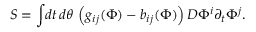<formula> <loc_0><loc_0><loc_500><loc_500>S = \int \, d t \, d \theta \, \left ( g _ { i j } ( \Phi ) - b _ { i j } ( \Phi ) \right ) D \Phi ^ { i } \partial _ { t } \Phi ^ { j } .</formula> 